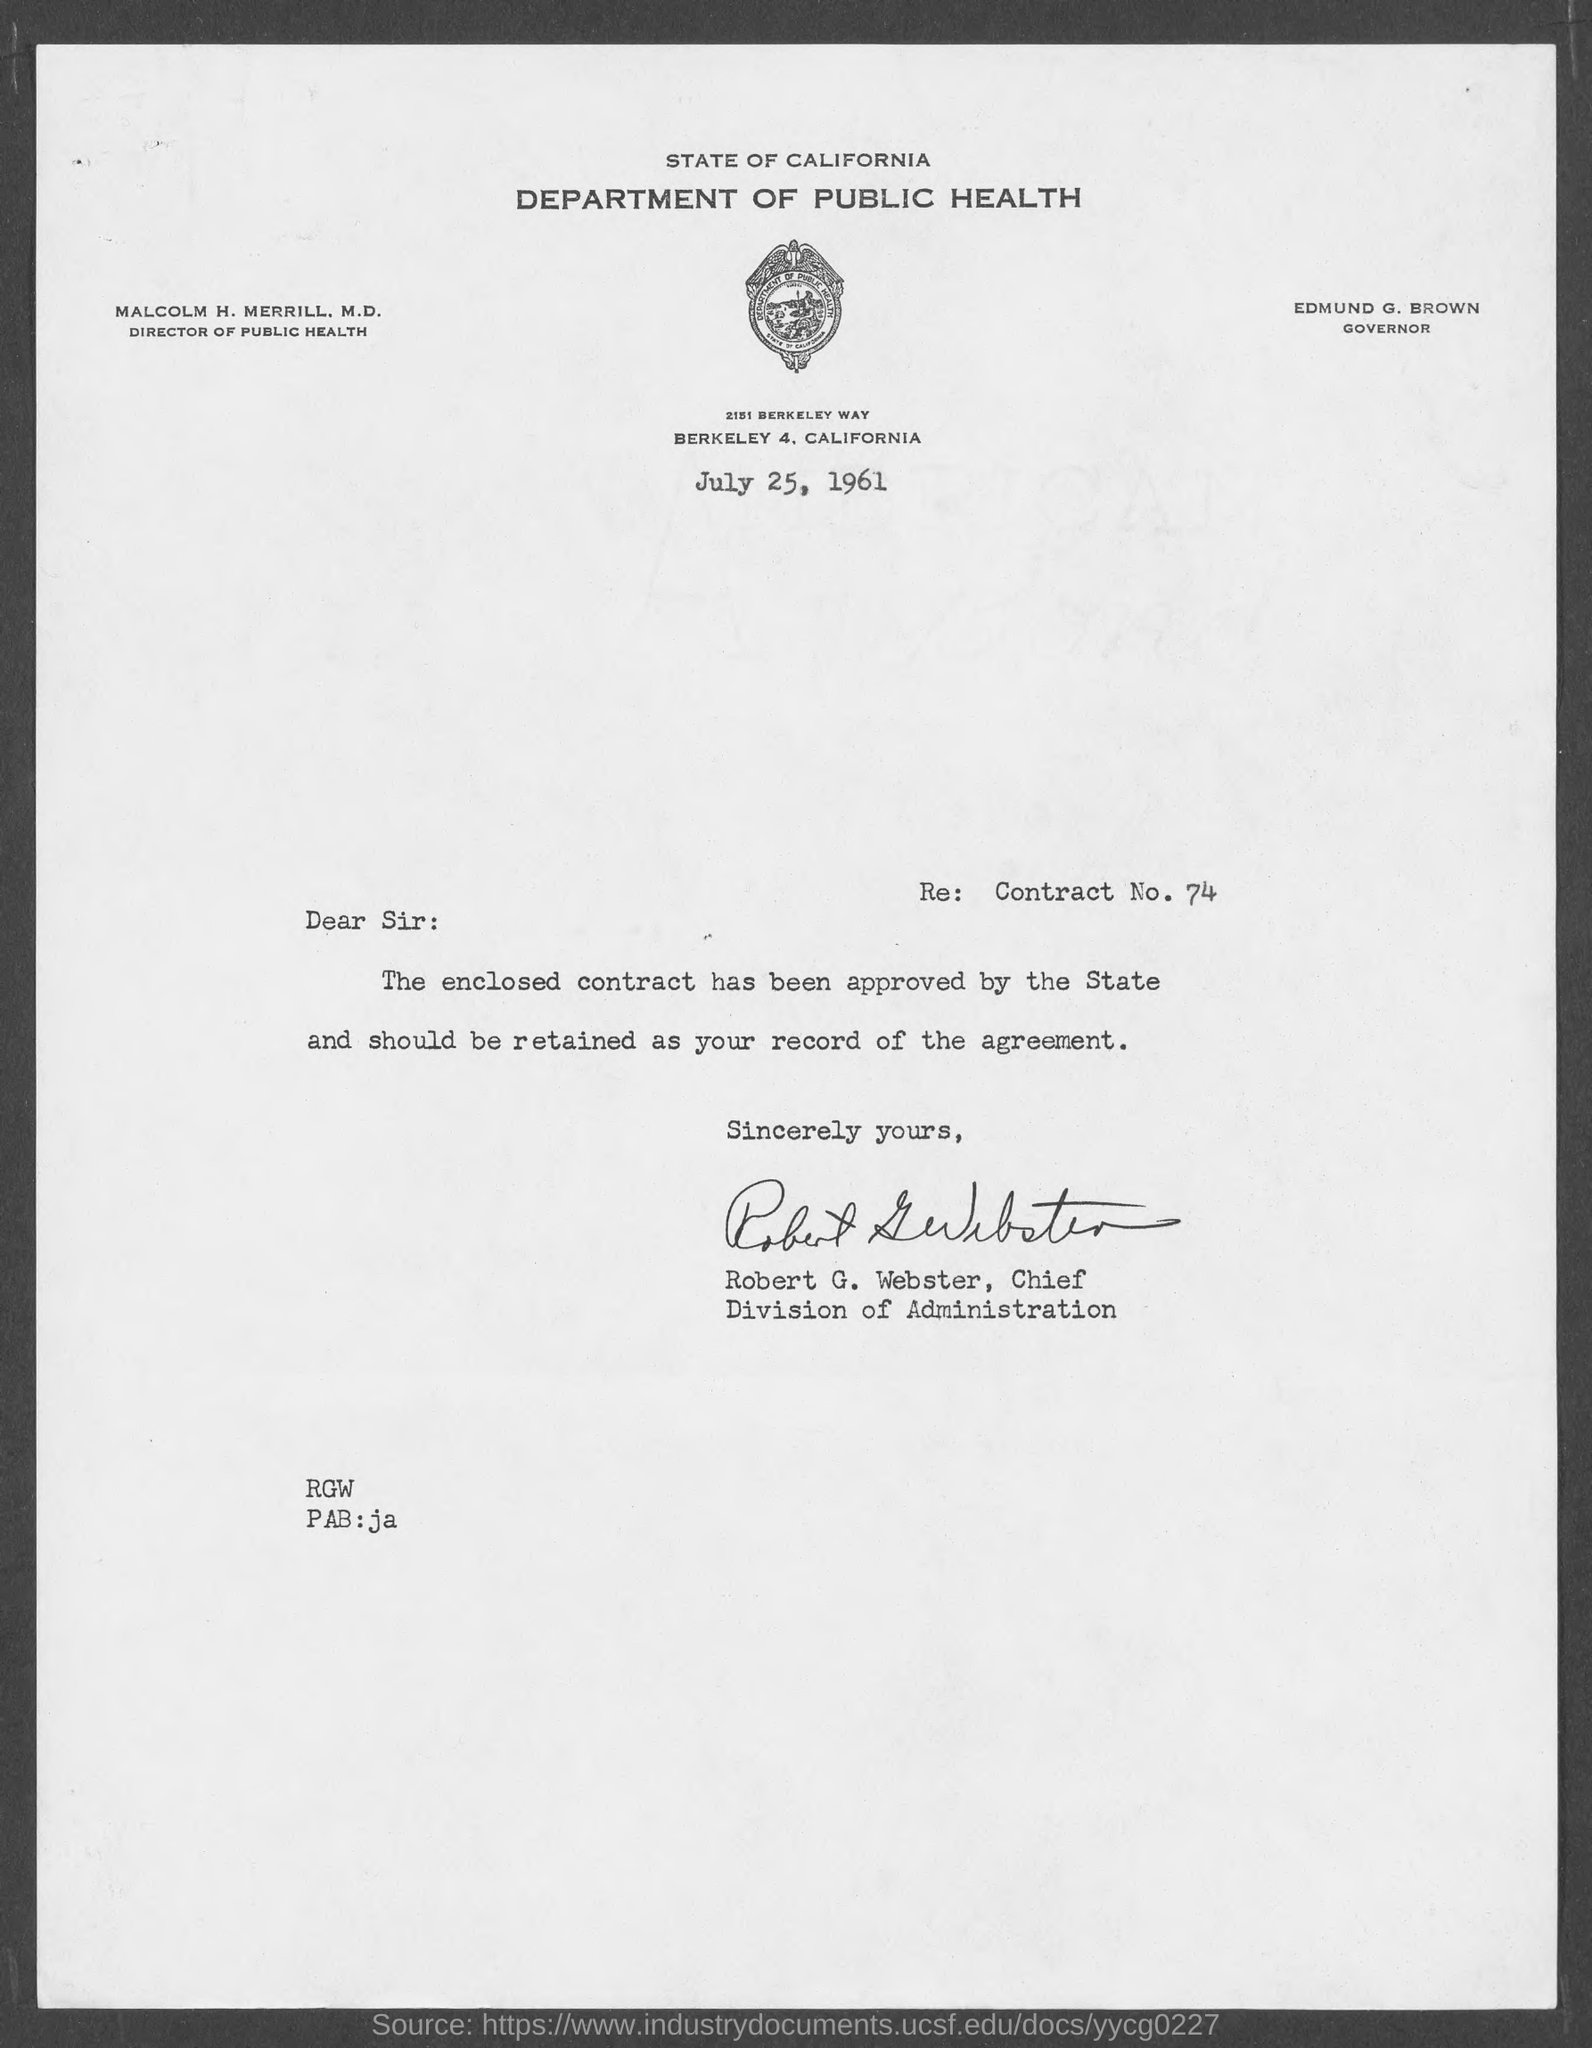Indicate a few pertinent items in this graphic. In the state of California, Edmund G. Brown served as the Governor of the Department of Health. This letter was sent on July 25, 1961. The letter was sent by Robert G. Webster. Malcolm H. Merrill, M.D., holds the designation of Director of Public Health in the Department of Public Health. 